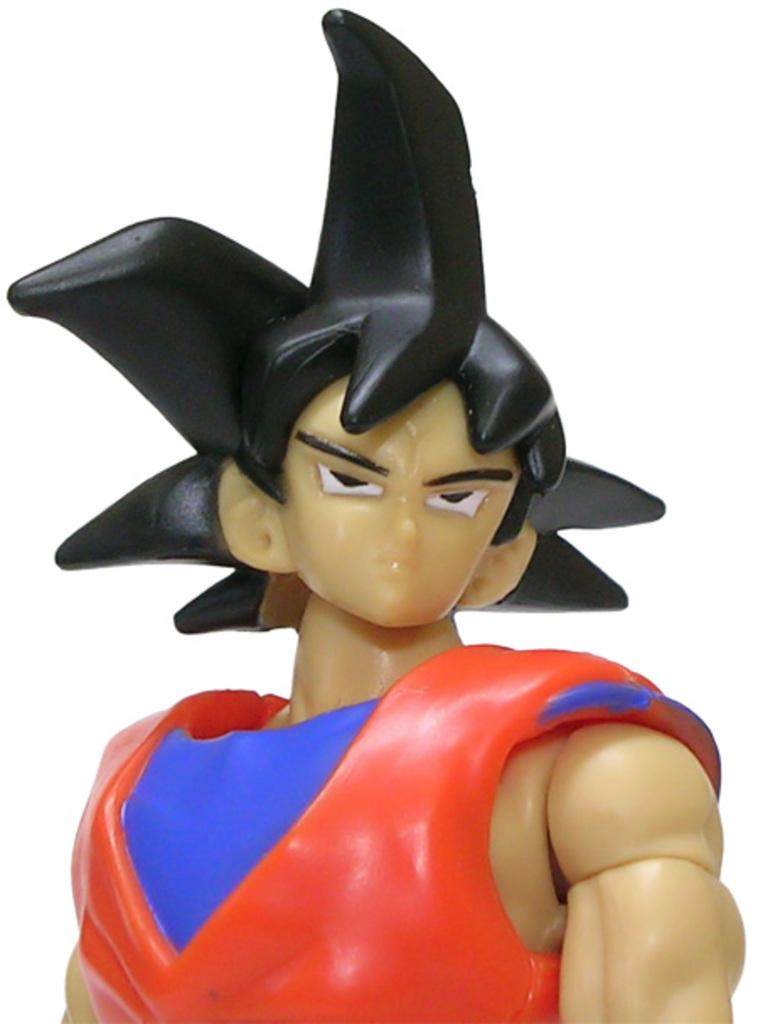What is the main subject of the image? There is a depiction of a person in the center of the image. What type of bed is the person sleeping on in the image? There is no bed present in the image; it only depicts a person in the center. 